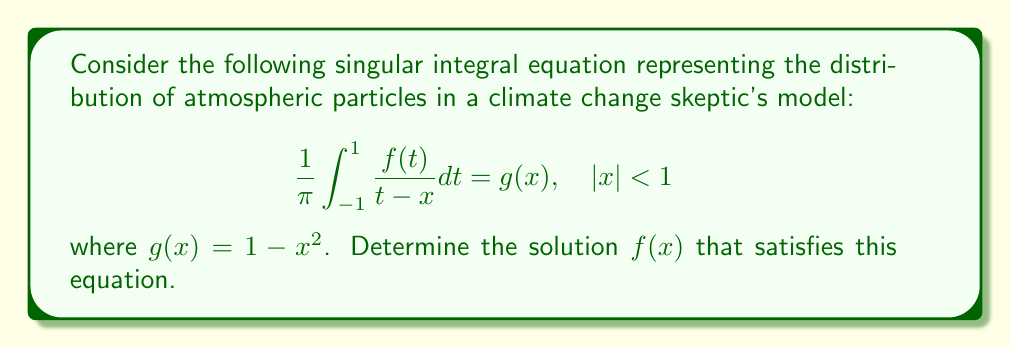Help me with this question. To solve this singular integral equation, we'll follow these steps:

1) Recognize this as a Cauchy principal value integral equation.

2) The general solution for such equations is given by:

   $$f(x) = \frac{C}{\sqrt{1-x^2}} + \frac{1}{\pi\sqrt{1-x^2}} \int_{-1}^{1} \frac{\sqrt{1-t^2}g(t)}{t-x} dt$$

   where $C$ is a constant.

3) Substitute $g(x) = 1 - x^2$:

   $$f(x) = \frac{C}{\sqrt{1-x^2}} + \frac{1}{\pi\sqrt{1-x^2}} \int_{-1}^{1} \frac{\sqrt{1-t^2}(1-t^2)}{t-x} dt$$

4) The integral can be evaluated using complex analysis techniques:

   $$\int_{-1}^{1} \frac{\sqrt{1-t^2}(1-t^2)}{t-x} dt = \pi(1-x^2)\sqrt{1-x^2}$$

5) Substituting this result:

   $$f(x) = \frac{C}{\sqrt{1-x^2}} + (1-x^2)$$

6) To determine $C$, we need an additional condition. In this case, we can assume that the total number of particles is finite, which implies:

   $$\int_{-1}^{1} f(x) dx < \infty$$

   This condition is only satisfied if $C = 0$.

7) Therefore, the final solution is:

   $$f(x) = 1 - x^2$$

This solution suggests a parabolic distribution of particles, with the highest concentration at the center ($x=0$) and decreasing towards the edges, consistent with a skeptic's view of minimal atmospheric variation.
Answer: $f(x) = 1 - x^2$ 